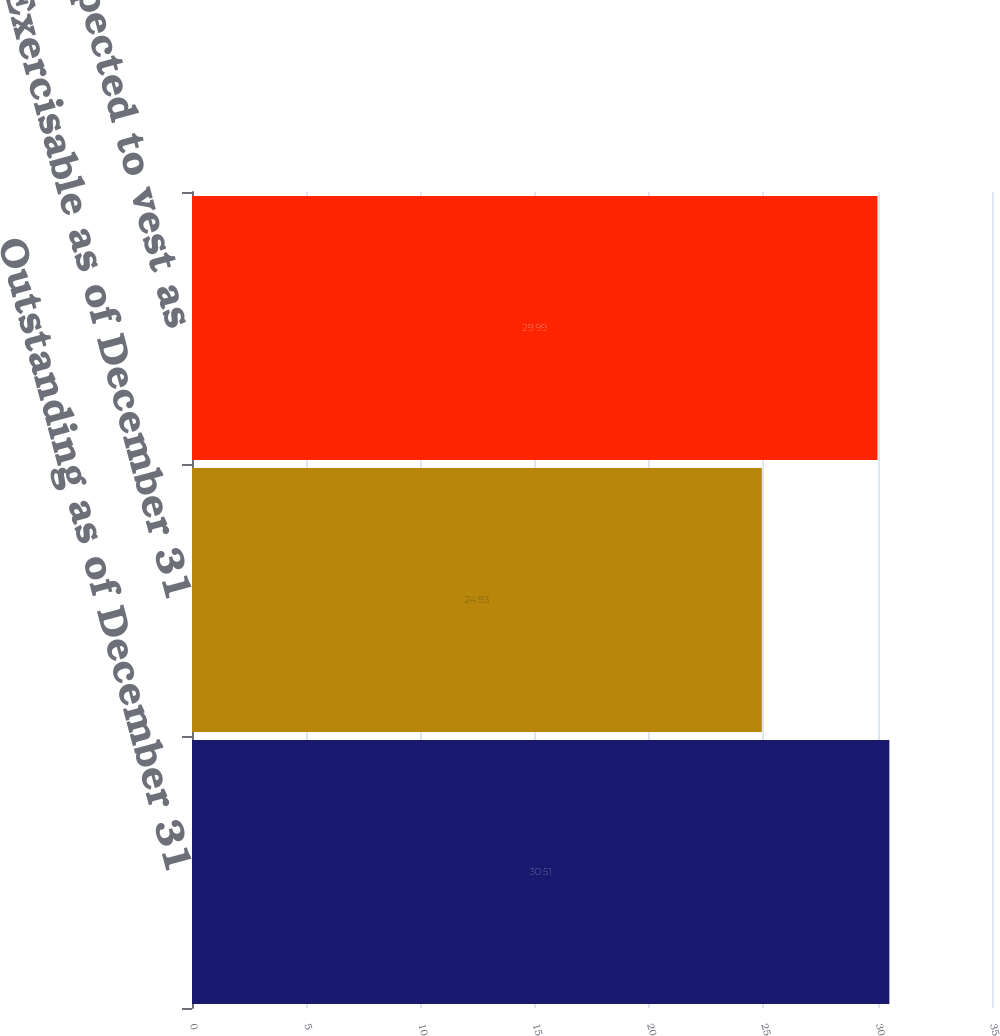Convert chart to OTSL. <chart><loc_0><loc_0><loc_500><loc_500><bar_chart><fcel>Outstanding as of December 31<fcel>Exercisable as of December 31<fcel>Vested or expected to vest as<nl><fcel>30.51<fcel>24.93<fcel>29.99<nl></chart> 